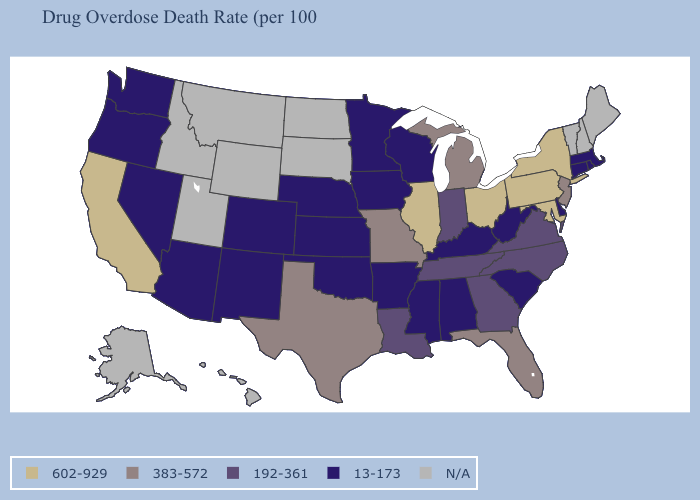What is the value of Illinois?
Quick response, please. 602-929. Does Missouri have the lowest value in the USA?
Short answer required. No. What is the value of South Dakota?
Answer briefly. N/A. What is the value of North Dakota?
Be succinct. N/A. Does the first symbol in the legend represent the smallest category?
Keep it brief. No. Name the states that have a value in the range 383-572?
Be succinct. Florida, Michigan, Missouri, New Jersey, Texas. Among the states that border Kentucky , does West Virginia have the lowest value?
Short answer required. Yes. What is the value of Texas?
Write a very short answer. 383-572. Which states have the highest value in the USA?
Write a very short answer. California, Illinois, Maryland, New York, Ohio, Pennsylvania. How many symbols are there in the legend?
Keep it brief. 5. What is the value of Washington?
Quick response, please. 13-173. Name the states that have a value in the range 13-173?
Keep it brief. Alabama, Arizona, Arkansas, Colorado, Connecticut, Delaware, Iowa, Kansas, Kentucky, Massachusetts, Minnesota, Mississippi, Nebraska, Nevada, New Mexico, Oklahoma, Oregon, Rhode Island, South Carolina, Washington, West Virginia, Wisconsin. Name the states that have a value in the range 383-572?
Write a very short answer. Florida, Michigan, Missouri, New Jersey, Texas. 